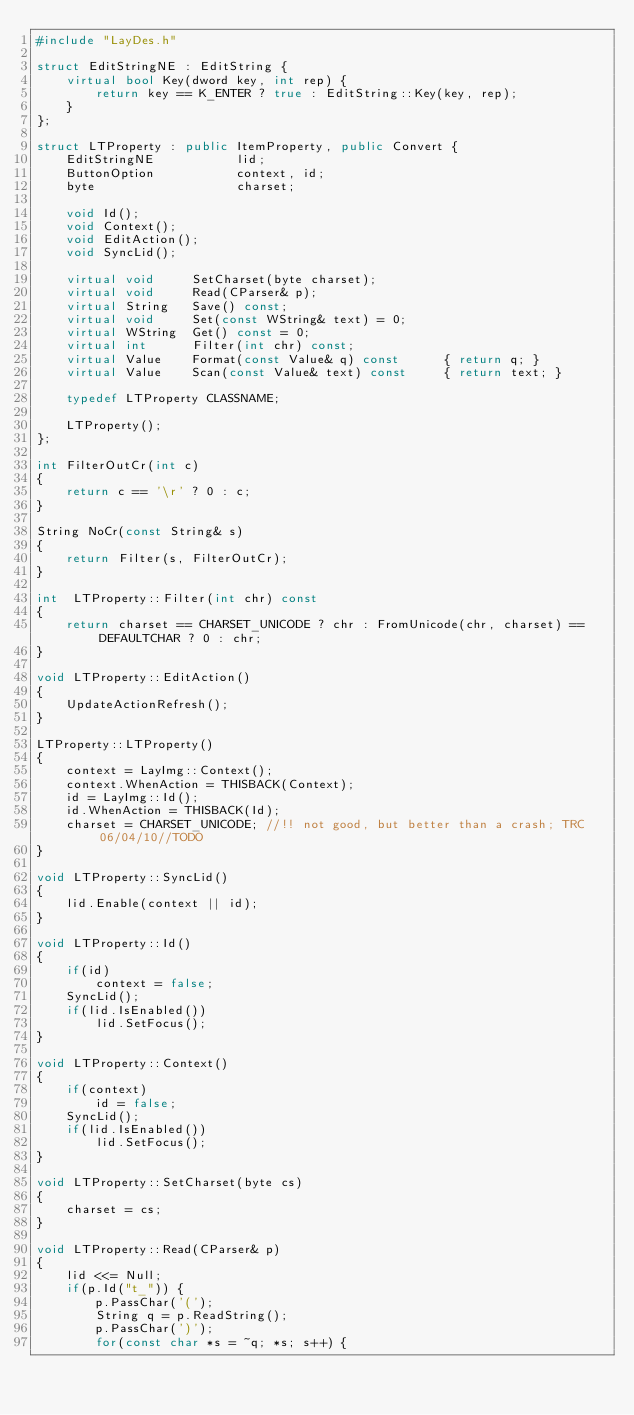Convert code to text. <code><loc_0><loc_0><loc_500><loc_500><_C++_>#include "LayDes.h"

struct EditStringNE : EditString {
	virtual bool Key(dword key, int rep) {
		return key == K_ENTER ? true : EditString::Key(key, rep);
	}
};

struct LTProperty : public ItemProperty, public Convert {
	EditStringNE           lid;
	ButtonOption           context, id;
	byte                   charset;

	void Id();
	void Context();
	void EditAction();
	void SyncLid();

	virtual void     SetCharset(byte charset);
	virtual void     Read(CParser& p);
	virtual String   Save() const;
	virtual void     Set(const WString& text) = 0;
	virtual WString  Get() const = 0;
	virtual int      Filter(int chr) const;
	virtual Value    Format(const Value& q) const      { return q; }
	virtual Value    Scan(const Value& text) const     { return text; }

	typedef LTProperty CLASSNAME;

	LTProperty();
};

int FilterOutCr(int c)
{
	return c == '\r' ? 0 : c;
}

String NoCr(const String& s)
{
	return Filter(s, FilterOutCr);
}

int  LTProperty::Filter(int chr) const
{
	return charset == CHARSET_UNICODE ? chr : FromUnicode(chr, charset) == DEFAULTCHAR ? 0 : chr;
}

void LTProperty::EditAction()
{
	UpdateActionRefresh();
}

LTProperty::LTProperty()
{
	context = LayImg::Context();
	context.WhenAction = THISBACK(Context);
	id = LayImg::Id();
	id.WhenAction = THISBACK(Id);
	charset = CHARSET_UNICODE; //!! not good, but better than a crash; TRC 06/04/10//TODO
}

void LTProperty::SyncLid()
{
	lid.Enable(context || id);
}

void LTProperty::Id()
{
	if(id)
		context = false;
	SyncLid();
	if(lid.IsEnabled())
		lid.SetFocus();
}

void LTProperty::Context()
{
	if(context)
		id = false;
	SyncLid();
	if(lid.IsEnabled())
		lid.SetFocus();
}

void LTProperty::SetCharset(byte cs)
{
	charset = cs;
}

void LTProperty::Read(CParser& p)
{
	lid <<= Null;
	if(p.Id("t_")) {
		p.PassChar('(');
		String q = p.ReadString();
		p.PassChar(')');
		for(const char *s = ~q; *s; s++) {</code> 